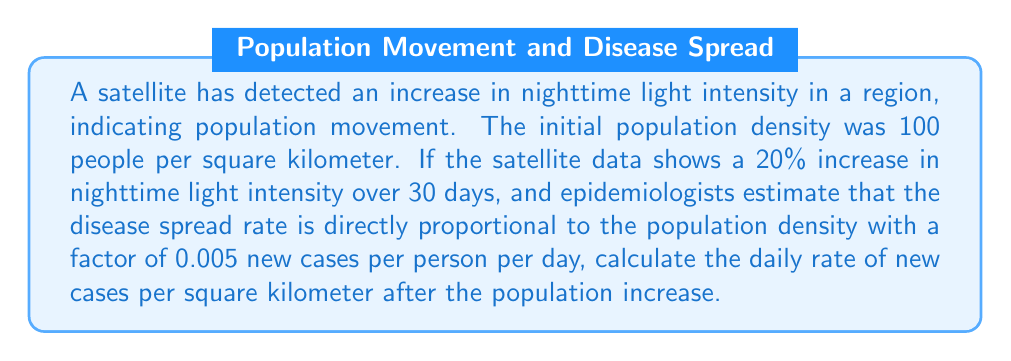Give your solution to this math problem. Let's approach this step-by-step:

1) First, we need to calculate the new population density after the 20% increase:
   Initial density = 100 people/km²
   Increase = 20% = 0.2
   New density = Initial density * (1 + Increase)
   $$ \text{New density} = 100 * (1 + 0.2) = 100 * 1.2 = 120 \text{ people/km²} $$

2) Now, we use the given information that the disease spread rate is directly proportional to the population density with a factor of 0.005 new cases per person per day.

3) We can express this as a linear equation:
   $$ \text{Rate of new cases} = 0.005 * \text{Population density} $$

4) Plugging in our new population density:
   $$ \text{Rate of new cases} = 0.005 * 120 $$

5) Calculating the result:
   $$ \text{Rate of new cases} = 0.6 \text{ new cases per km² per day} $$

This means that after the population increase, we expect 0.6 new cases to appear daily in each square kilometer of the affected area.
Answer: $0.6 \text{ new cases}/(\text{km}^2 \cdot \text{day})$ 